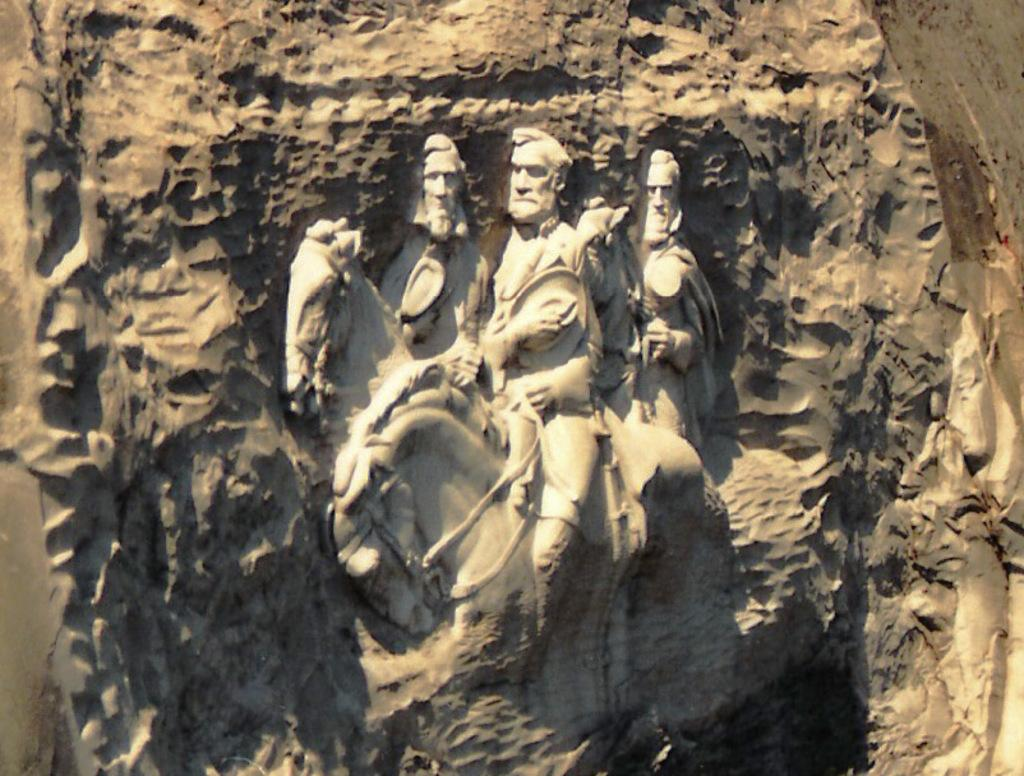What is the main subject of the image? The main subject of the image is sculptures of three persons. What are the persons depicted as doing in the sculptures? The persons are depicted as riding horses in the sculptures. Where are the sculptures located? The sculptures are on a rock. What is the color of the background in the image? The background of the image is gray in color. Can you tell me how many corks are used in the sculptures? There are no corks used in the sculptures; the sculptures are made of a different material, likely stone or metal. Is the family depicted in the sculptures? The provided facts do not mention a family, only three persons riding horses. 